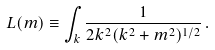Convert formula to latex. <formula><loc_0><loc_0><loc_500><loc_500>L ( m ) \equiv \int _ { k } \frac { 1 } { 2 { k } ^ { 2 } ( { k } ^ { 2 } + m ^ { 2 } ) ^ { 1 / 2 } } \, .</formula> 